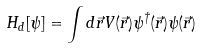Convert formula to latex. <formula><loc_0><loc_0><loc_500><loc_500>H _ { d } [ \psi ] = \int d \vec { r } V ( \vec { r } ) \psi ^ { \dag } ( \vec { r } ) \psi ( \vec { r } )</formula> 